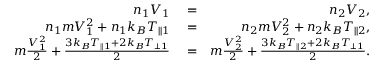<formula> <loc_0><loc_0><loc_500><loc_500>\begin{array} { r l r } { n _ { 1 } V _ { 1 } } & = } & { n _ { 2 } V _ { 2 } , } \\ { n _ { 1 } m V _ { 1 } ^ { 2 } + n _ { 1 } k _ { B } T _ { \| 1 } } & = } & { n _ { 2 } m V _ { 2 } ^ { 2 } + n _ { 2 } k _ { B } T _ { \| 2 } , } \\ { m \frac { V _ { 1 } ^ { 2 } } { 2 } + \frac { 3 k _ { B } T _ { \| 1 } + 2 k _ { B } T _ { \perp 1 } } { 2 } } & = } & { m \frac { V _ { 2 } ^ { 2 } } { 2 } + \frac { 3 k _ { B } T _ { \| 2 } + 2 k _ { B } T _ { \perp 1 } } { 2 } . } \end{array}</formula> 